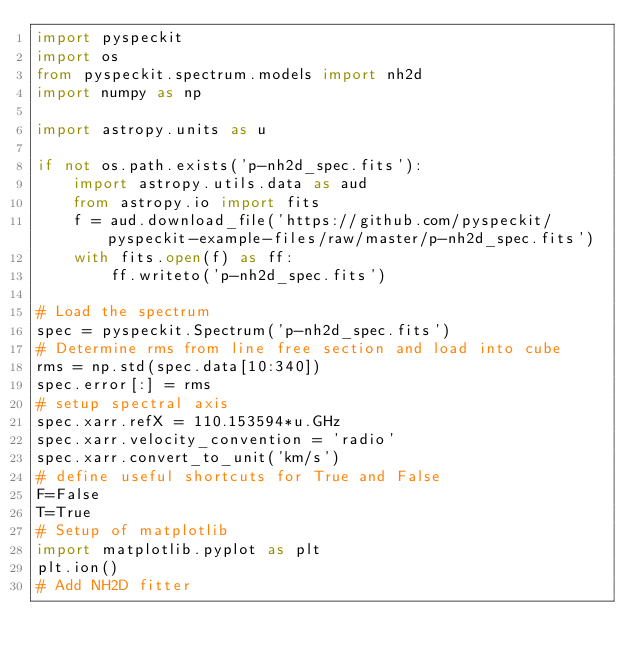<code> <loc_0><loc_0><loc_500><loc_500><_Python_>import pyspeckit
import os
from pyspeckit.spectrum.models import nh2d
import numpy as np

import astropy.units as u

if not os.path.exists('p-nh2d_spec.fits'):
    import astropy.utils.data as aud
    from astropy.io import fits
    f = aud.download_file('https://github.com/pyspeckit/pyspeckit-example-files/raw/master/p-nh2d_spec.fits')
    with fits.open(f) as ff:
        ff.writeto('p-nh2d_spec.fits')

# Load the spectrum 
spec = pyspeckit.Spectrum('p-nh2d_spec.fits')
# Determine rms from line free section and load into cube
rms = np.std(spec.data[10:340])
spec.error[:] = rms
# setup spectral axis
spec.xarr.refX = 110.153594*u.GHz
spec.xarr.velocity_convention = 'radio'
spec.xarr.convert_to_unit('km/s')
# define useful shortcuts for True and False
F=False
T=True
# Setup of matplotlib
import matplotlib.pyplot as plt
plt.ion()
# Add NH2D fitter</code> 